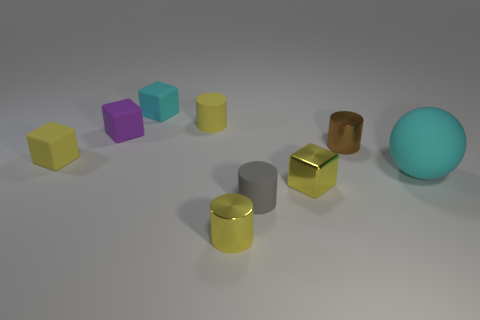Are there fewer tiny cyan cylinders than tiny cyan rubber things?
Your answer should be very brief. Yes. Is there any other thing of the same color as the shiny block?
Offer a terse response. Yes. What shape is the cyan object that is the same material as the large cyan sphere?
Make the answer very short. Cube. There is a small rubber block in front of the tiny metallic thing behind the small metal block; how many small rubber cylinders are left of it?
Offer a very short reply. 0. The rubber thing that is behind the gray rubber cylinder and right of the yellow metallic cylinder has what shape?
Provide a short and direct response. Sphere. Are there fewer tiny yellow rubber things that are behind the gray matte cylinder than yellow cylinders?
Offer a terse response. No. What number of large objects are either purple matte blocks or cylinders?
Your answer should be very brief. 0. What size is the cyan cube?
Offer a terse response. Small. Is there anything else that has the same material as the purple cube?
Make the answer very short. Yes. How many tiny yellow metallic cylinders are left of the big rubber thing?
Your answer should be compact. 1. 